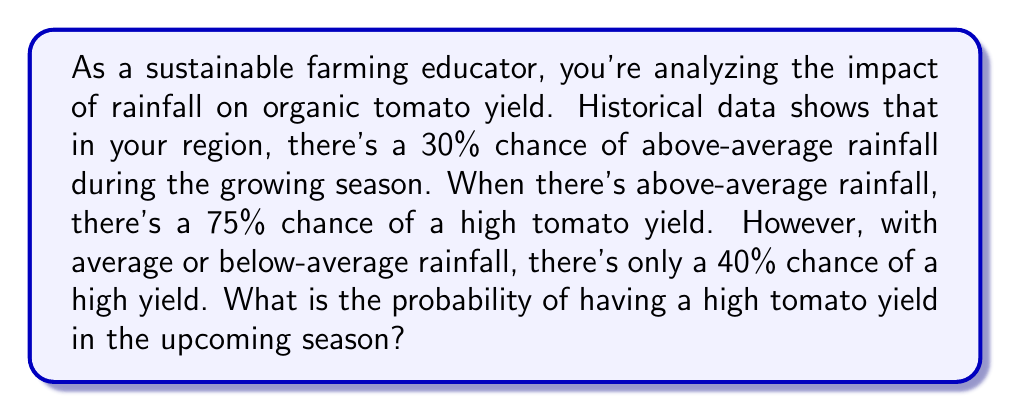Solve this math problem. Let's approach this step-by-step using conditional probability:

1) Define events:
   R: Above-average rainfall
   H: High tomato yield

2) Given probabilities:
   $P(R) = 0.30$
   $P(H|R) = 0.75$
   $P(H|\text{not }R) = 0.40$

3) We need to find $P(H)$. We can use the law of total probability:

   $P(H) = P(H|R) \cdot P(R) + P(H|\text{not }R) \cdot P(\text{not }R)$

4) We know $P(\text{not }R) = 1 - P(R) = 1 - 0.30 = 0.70$

5) Now, let's substitute the values:

   $P(H) = 0.75 \cdot 0.30 + 0.40 \cdot 0.70$

6) Calculate:
   $P(H) = 0.225 + 0.28 = 0.505$

Therefore, the probability of having a high tomato yield in the upcoming season is 0.505 or 50.5%.
Answer: 0.505 